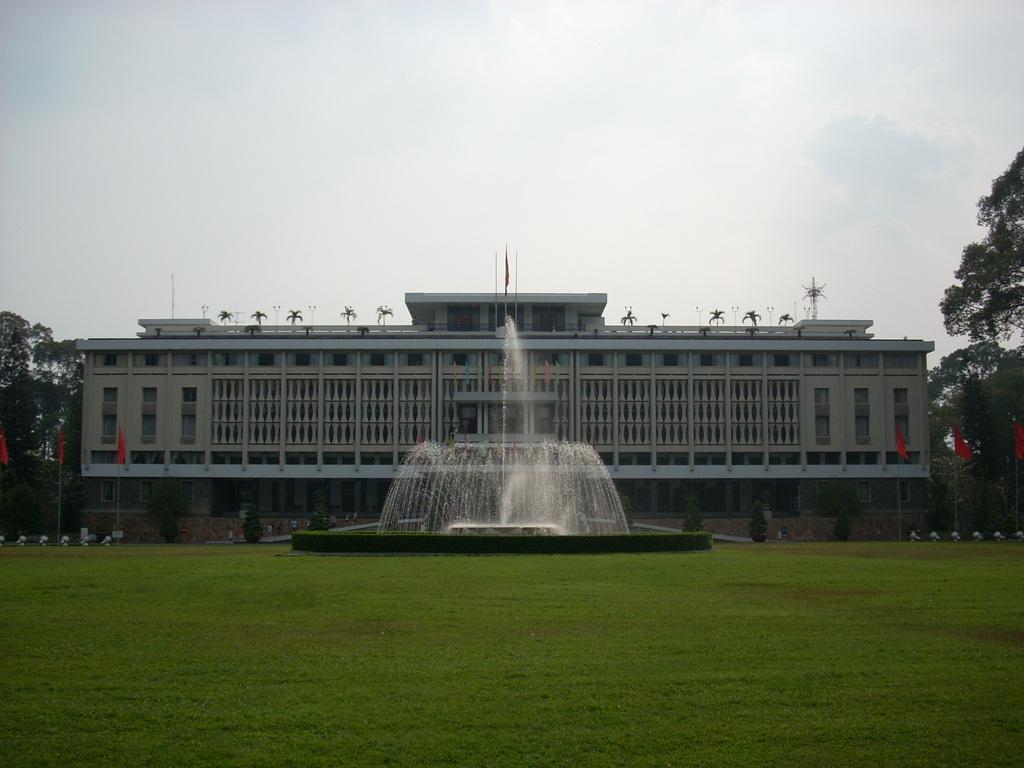How would you summarize this image in a sentence or two? At the center of the image there is a building, in front of the building there are trees, flags and a fountain, there is the surface of the grass and on the either side of the image there are trees. In the background there is the sky. 